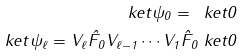Convert formula to latex. <formula><loc_0><loc_0><loc_500><loc_500>\ k e t { \psi _ { 0 } } = \ k e t { 0 } \\ \ k e t { \psi _ { \ell } } = V _ { \ell } \hat { F } _ { 0 } V _ { \ell - 1 } \cdots V _ { 1 } \hat { F } _ { 0 } \ k e t { 0 }</formula> 